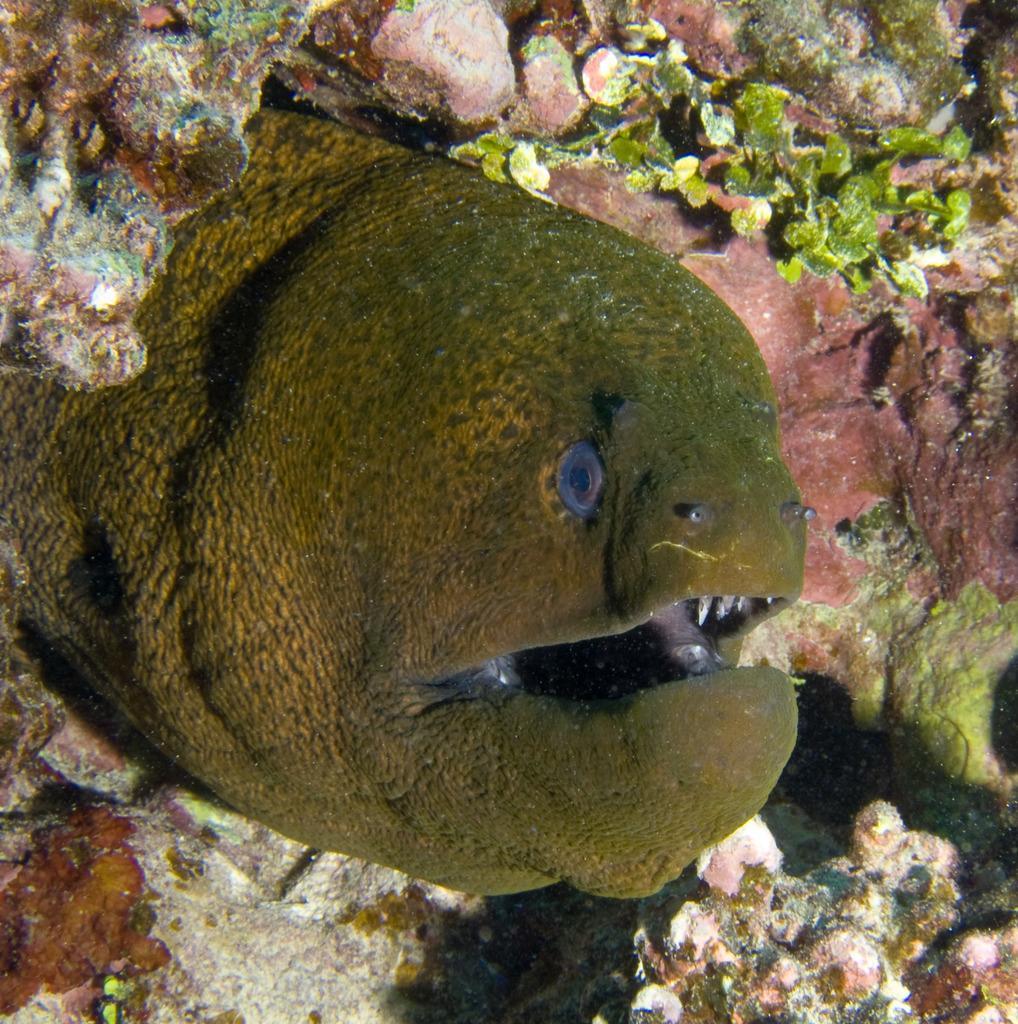In one or two sentences, can you explain what this image depicts? In this picture I can see a fish and corals in the water. 